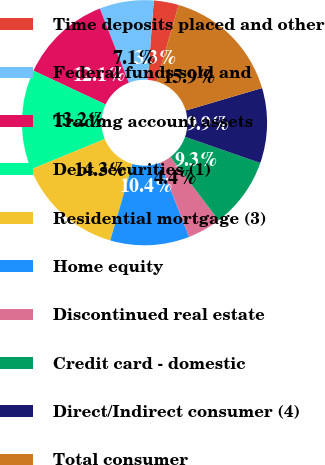<chart> <loc_0><loc_0><loc_500><loc_500><pie_chart><fcel>Time deposits placed and other<fcel>Federal funds sold and<fcel>Trading account assets<fcel>Debt securities (1)<fcel>Residential mortgage (3)<fcel>Home equity<fcel>Discontinued real estate<fcel>Credit card - domestic<fcel>Direct/Indirect consumer (4)<fcel>Total consumer<nl><fcel>3.3%<fcel>7.14%<fcel>12.09%<fcel>13.19%<fcel>14.29%<fcel>10.44%<fcel>4.4%<fcel>9.34%<fcel>9.89%<fcel>15.93%<nl></chart> 